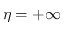Convert formula to latex. <formula><loc_0><loc_0><loc_500><loc_500>\eta = + \infty</formula> 